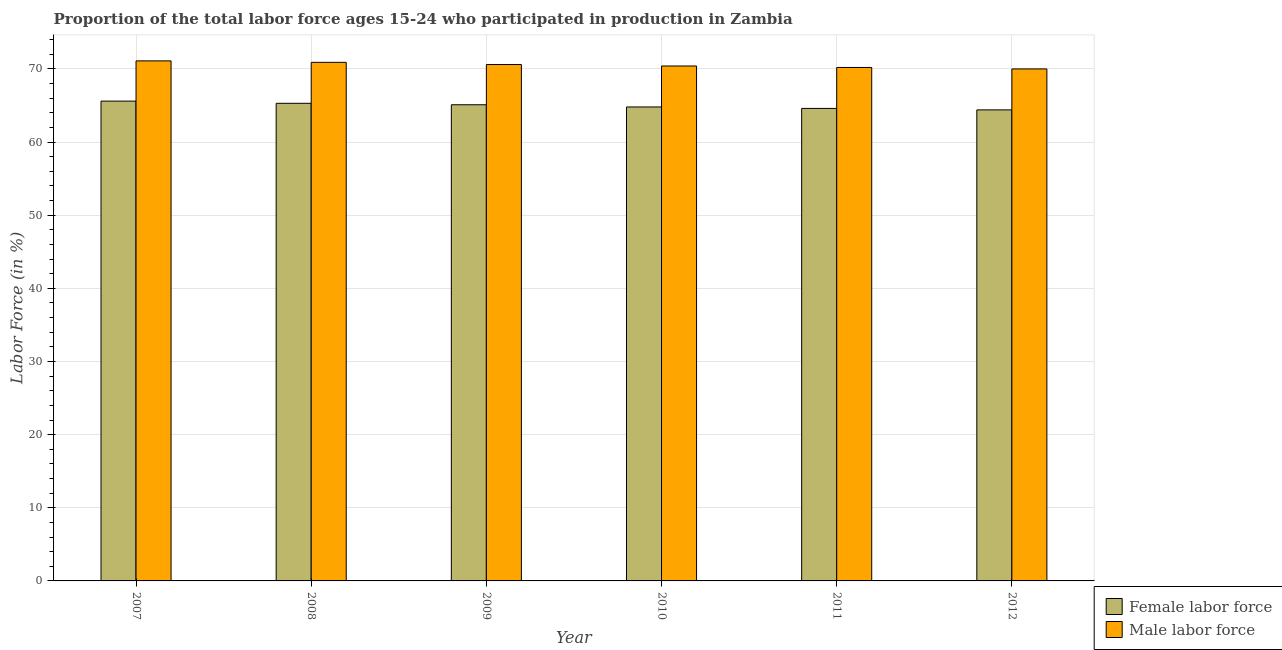How many bars are there on the 4th tick from the left?
Your answer should be very brief. 2. How many bars are there on the 4th tick from the right?
Give a very brief answer. 2. What is the label of the 1st group of bars from the left?
Make the answer very short. 2007. What is the percentage of female labor force in 2011?
Offer a terse response. 64.6. Across all years, what is the maximum percentage of female labor force?
Offer a terse response. 65.6. What is the total percentage of female labor force in the graph?
Offer a very short reply. 389.8. What is the difference between the percentage of female labor force in 2008 and that in 2009?
Offer a terse response. 0.2. What is the difference between the percentage of male labour force in 2010 and the percentage of female labor force in 2007?
Offer a very short reply. -0.7. What is the average percentage of male labour force per year?
Give a very brief answer. 70.53. What is the ratio of the percentage of male labour force in 2008 to that in 2012?
Give a very brief answer. 1.01. Is the difference between the percentage of female labor force in 2007 and 2009 greater than the difference between the percentage of male labour force in 2007 and 2009?
Provide a succinct answer. No. What is the difference between the highest and the second highest percentage of male labour force?
Provide a short and direct response. 0.2. What is the difference between the highest and the lowest percentage of female labor force?
Make the answer very short. 1.2. In how many years, is the percentage of male labour force greater than the average percentage of male labour force taken over all years?
Offer a terse response. 3. Is the sum of the percentage of male labour force in 2010 and 2012 greater than the maximum percentage of female labor force across all years?
Give a very brief answer. Yes. What does the 2nd bar from the left in 2007 represents?
Provide a succinct answer. Male labor force. What does the 1st bar from the right in 2009 represents?
Ensure brevity in your answer.  Male labor force. How many bars are there?
Give a very brief answer. 12. How many years are there in the graph?
Your response must be concise. 6. What is the difference between two consecutive major ticks on the Y-axis?
Give a very brief answer. 10. Are the values on the major ticks of Y-axis written in scientific E-notation?
Ensure brevity in your answer.  No. Where does the legend appear in the graph?
Your answer should be compact. Bottom right. How many legend labels are there?
Make the answer very short. 2. What is the title of the graph?
Provide a succinct answer. Proportion of the total labor force ages 15-24 who participated in production in Zambia. What is the label or title of the X-axis?
Provide a short and direct response. Year. What is the Labor Force (in %) in Female labor force in 2007?
Give a very brief answer. 65.6. What is the Labor Force (in %) in Male labor force in 2007?
Make the answer very short. 71.1. What is the Labor Force (in %) of Female labor force in 2008?
Your answer should be very brief. 65.3. What is the Labor Force (in %) of Male labor force in 2008?
Offer a terse response. 70.9. What is the Labor Force (in %) of Female labor force in 2009?
Offer a terse response. 65.1. What is the Labor Force (in %) of Male labor force in 2009?
Your answer should be compact. 70.6. What is the Labor Force (in %) in Female labor force in 2010?
Your answer should be very brief. 64.8. What is the Labor Force (in %) in Male labor force in 2010?
Give a very brief answer. 70.4. What is the Labor Force (in %) in Female labor force in 2011?
Provide a succinct answer. 64.6. What is the Labor Force (in %) of Male labor force in 2011?
Your answer should be compact. 70.2. What is the Labor Force (in %) in Female labor force in 2012?
Ensure brevity in your answer.  64.4. What is the Labor Force (in %) of Male labor force in 2012?
Provide a short and direct response. 70. Across all years, what is the maximum Labor Force (in %) in Female labor force?
Provide a short and direct response. 65.6. Across all years, what is the maximum Labor Force (in %) in Male labor force?
Give a very brief answer. 71.1. Across all years, what is the minimum Labor Force (in %) of Female labor force?
Your answer should be compact. 64.4. What is the total Labor Force (in %) in Female labor force in the graph?
Your answer should be very brief. 389.8. What is the total Labor Force (in %) of Male labor force in the graph?
Your answer should be compact. 423.2. What is the difference between the Labor Force (in %) of Female labor force in 2007 and that in 2010?
Give a very brief answer. 0.8. What is the difference between the Labor Force (in %) of Male labor force in 2007 and that in 2010?
Keep it short and to the point. 0.7. What is the difference between the Labor Force (in %) of Female labor force in 2007 and that in 2012?
Provide a succinct answer. 1.2. What is the difference between the Labor Force (in %) in Male labor force in 2007 and that in 2012?
Offer a terse response. 1.1. What is the difference between the Labor Force (in %) of Male labor force in 2008 and that in 2010?
Give a very brief answer. 0.5. What is the difference between the Labor Force (in %) of Female labor force in 2008 and that in 2011?
Your answer should be very brief. 0.7. What is the difference between the Labor Force (in %) in Male labor force in 2008 and that in 2011?
Provide a short and direct response. 0.7. What is the difference between the Labor Force (in %) in Male labor force in 2008 and that in 2012?
Make the answer very short. 0.9. What is the difference between the Labor Force (in %) of Female labor force in 2009 and that in 2011?
Your answer should be compact. 0.5. What is the difference between the Labor Force (in %) of Male labor force in 2009 and that in 2011?
Offer a very short reply. 0.4. What is the difference between the Labor Force (in %) in Female labor force in 2007 and the Labor Force (in %) in Male labor force in 2008?
Ensure brevity in your answer.  -5.3. What is the difference between the Labor Force (in %) of Female labor force in 2007 and the Labor Force (in %) of Male labor force in 2009?
Make the answer very short. -5. What is the difference between the Labor Force (in %) of Female labor force in 2007 and the Labor Force (in %) of Male labor force in 2010?
Provide a short and direct response. -4.8. What is the difference between the Labor Force (in %) in Female labor force in 2007 and the Labor Force (in %) in Male labor force in 2011?
Your answer should be compact. -4.6. What is the difference between the Labor Force (in %) in Female labor force in 2007 and the Labor Force (in %) in Male labor force in 2012?
Your response must be concise. -4.4. What is the difference between the Labor Force (in %) in Female labor force in 2008 and the Labor Force (in %) in Male labor force in 2009?
Provide a short and direct response. -5.3. What is the difference between the Labor Force (in %) of Female labor force in 2008 and the Labor Force (in %) of Male labor force in 2010?
Give a very brief answer. -5.1. What is the difference between the Labor Force (in %) of Female labor force in 2008 and the Labor Force (in %) of Male labor force in 2011?
Make the answer very short. -4.9. What is the difference between the Labor Force (in %) in Female labor force in 2008 and the Labor Force (in %) in Male labor force in 2012?
Give a very brief answer. -4.7. What is the difference between the Labor Force (in %) in Female labor force in 2009 and the Labor Force (in %) in Male labor force in 2010?
Ensure brevity in your answer.  -5.3. What is the difference between the Labor Force (in %) in Female labor force in 2009 and the Labor Force (in %) in Male labor force in 2012?
Make the answer very short. -4.9. What is the difference between the Labor Force (in %) in Female labor force in 2010 and the Labor Force (in %) in Male labor force in 2011?
Your response must be concise. -5.4. What is the difference between the Labor Force (in %) of Female labor force in 2011 and the Labor Force (in %) of Male labor force in 2012?
Your answer should be very brief. -5.4. What is the average Labor Force (in %) of Female labor force per year?
Offer a terse response. 64.97. What is the average Labor Force (in %) of Male labor force per year?
Provide a succinct answer. 70.53. In the year 2007, what is the difference between the Labor Force (in %) of Female labor force and Labor Force (in %) of Male labor force?
Keep it short and to the point. -5.5. In the year 2009, what is the difference between the Labor Force (in %) in Female labor force and Labor Force (in %) in Male labor force?
Your answer should be compact. -5.5. What is the ratio of the Labor Force (in %) of Female labor force in 2007 to that in 2008?
Your response must be concise. 1. What is the ratio of the Labor Force (in %) in Female labor force in 2007 to that in 2009?
Your answer should be compact. 1.01. What is the ratio of the Labor Force (in %) of Male labor force in 2007 to that in 2009?
Give a very brief answer. 1.01. What is the ratio of the Labor Force (in %) of Female labor force in 2007 to that in 2010?
Your answer should be very brief. 1.01. What is the ratio of the Labor Force (in %) in Male labor force in 2007 to that in 2010?
Your answer should be very brief. 1.01. What is the ratio of the Labor Force (in %) in Female labor force in 2007 to that in 2011?
Your answer should be very brief. 1.02. What is the ratio of the Labor Force (in %) of Male labor force in 2007 to that in 2011?
Ensure brevity in your answer.  1.01. What is the ratio of the Labor Force (in %) of Female labor force in 2007 to that in 2012?
Your response must be concise. 1.02. What is the ratio of the Labor Force (in %) in Male labor force in 2007 to that in 2012?
Make the answer very short. 1.02. What is the ratio of the Labor Force (in %) in Female labor force in 2008 to that in 2010?
Your response must be concise. 1.01. What is the ratio of the Labor Force (in %) in Male labor force in 2008 to that in 2010?
Make the answer very short. 1.01. What is the ratio of the Labor Force (in %) in Female labor force in 2008 to that in 2011?
Make the answer very short. 1.01. What is the ratio of the Labor Force (in %) of Female labor force in 2008 to that in 2012?
Your answer should be compact. 1.01. What is the ratio of the Labor Force (in %) in Male labor force in 2008 to that in 2012?
Provide a short and direct response. 1.01. What is the ratio of the Labor Force (in %) of Female labor force in 2009 to that in 2010?
Provide a succinct answer. 1. What is the ratio of the Labor Force (in %) in Male labor force in 2009 to that in 2010?
Make the answer very short. 1. What is the ratio of the Labor Force (in %) of Female labor force in 2009 to that in 2011?
Offer a very short reply. 1.01. What is the ratio of the Labor Force (in %) in Female labor force in 2009 to that in 2012?
Give a very brief answer. 1.01. What is the ratio of the Labor Force (in %) in Male labor force in 2009 to that in 2012?
Your answer should be compact. 1.01. What is the ratio of the Labor Force (in %) in Male labor force in 2010 to that in 2012?
Your answer should be very brief. 1.01. What is the ratio of the Labor Force (in %) of Male labor force in 2011 to that in 2012?
Make the answer very short. 1. What is the difference between the highest and the second highest Labor Force (in %) in Male labor force?
Offer a terse response. 0.2. What is the difference between the highest and the lowest Labor Force (in %) of Female labor force?
Your answer should be very brief. 1.2. What is the difference between the highest and the lowest Labor Force (in %) of Male labor force?
Your answer should be very brief. 1.1. 